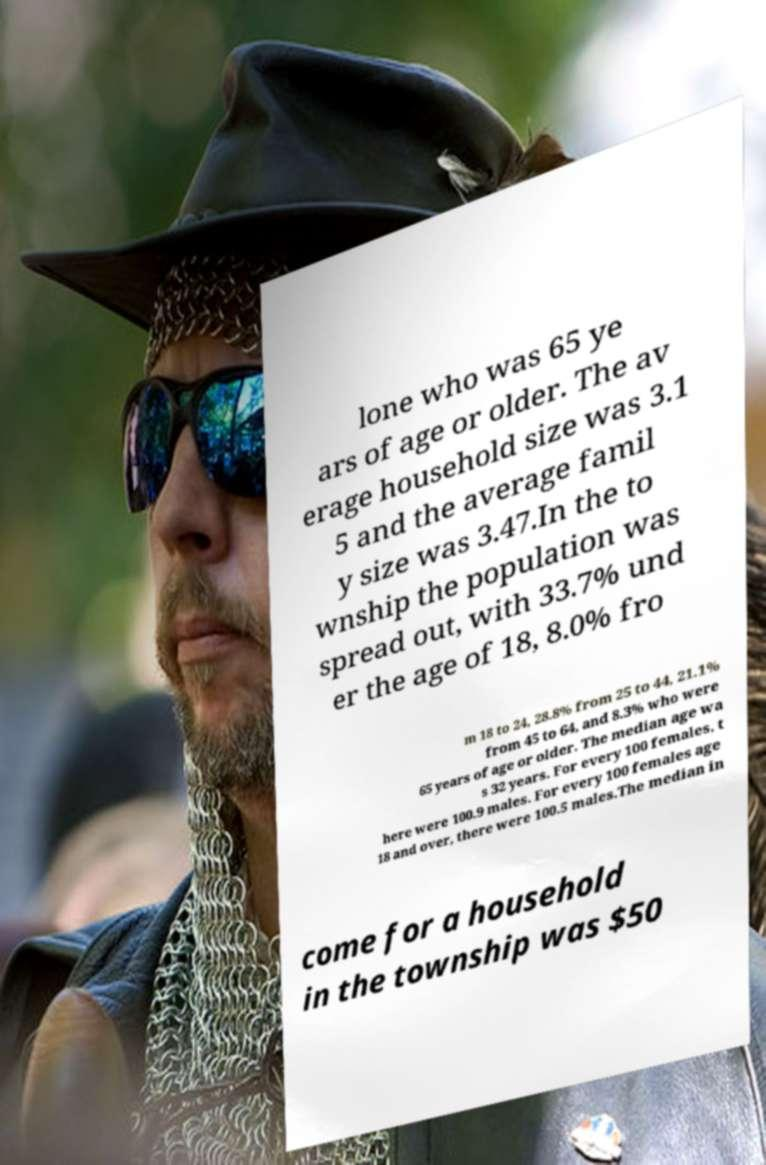There's text embedded in this image that I need extracted. Can you transcribe it verbatim? lone who was 65 ye ars of age or older. The av erage household size was 3.1 5 and the average famil y size was 3.47.In the to wnship the population was spread out, with 33.7% und er the age of 18, 8.0% fro m 18 to 24, 28.8% from 25 to 44, 21.1% from 45 to 64, and 8.3% who were 65 years of age or older. The median age wa s 32 years. For every 100 females, t here were 100.9 males. For every 100 females age 18 and over, there were 100.5 males.The median in come for a household in the township was $50 